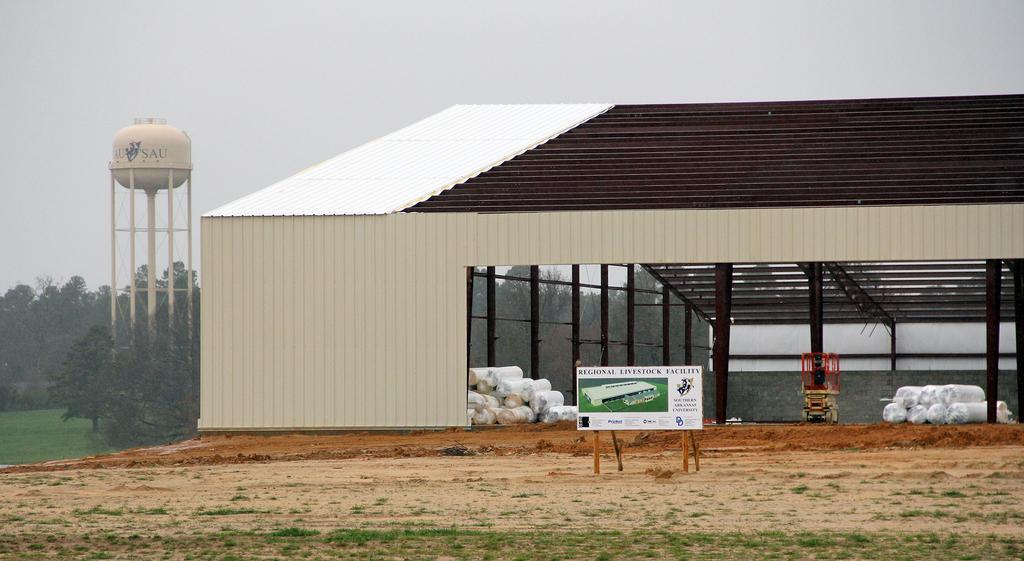How would you summarize this image in a sentence or two? In this image, we can see a shed and in the background, there are trees and we can see a board with some text and there is a tower and we can see some objects and a machine on the ground. At the top, there is sky. 